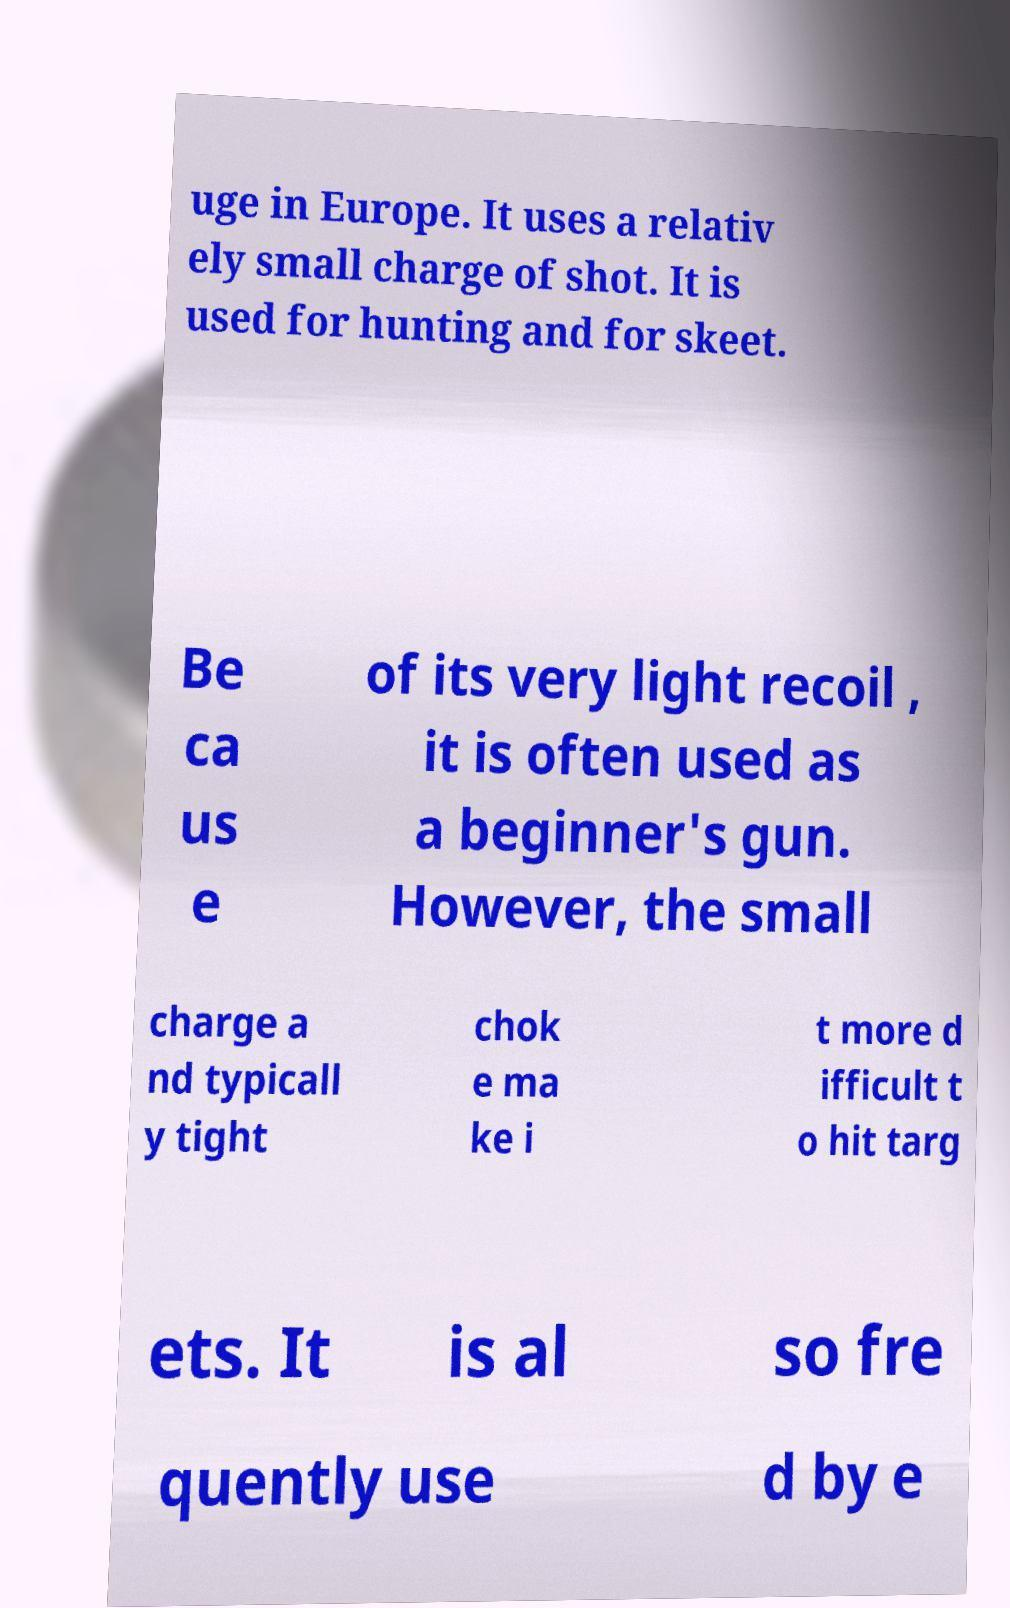Please identify and transcribe the text found in this image. uge in Europe. It uses a relativ ely small charge of shot. It is used for hunting and for skeet. Be ca us e of its very light recoil , it is often used as a beginner's gun. However, the small charge a nd typicall y tight chok e ma ke i t more d ifficult t o hit targ ets. It is al so fre quently use d by e 